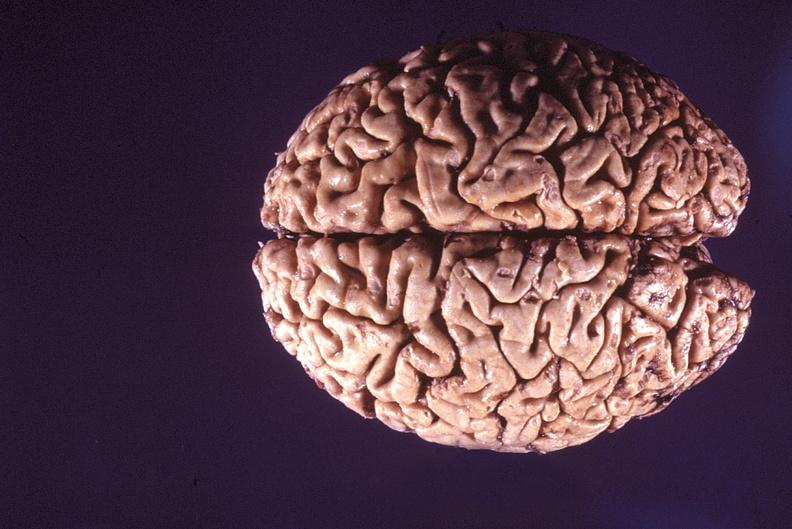s nervous present?
Answer the question using a single word or phrase. Yes 